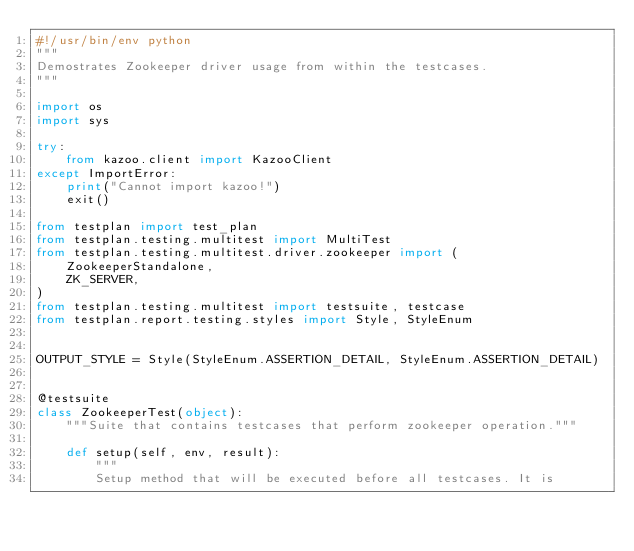<code> <loc_0><loc_0><loc_500><loc_500><_Python_>#!/usr/bin/env python
"""
Demostrates Zookeeper driver usage from within the testcases.
"""

import os
import sys

try:
    from kazoo.client import KazooClient
except ImportError:
    print("Cannot import kazoo!")
    exit()

from testplan import test_plan
from testplan.testing.multitest import MultiTest
from testplan.testing.multitest.driver.zookeeper import (
    ZookeeperStandalone,
    ZK_SERVER,
)
from testplan.testing.multitest import testsuite, testcase
from testplan.report.testing.styles import Style, StyleEnum


OUTPUT_STYLE = Style(StyleEnum.ASSERTION_DETAIL, StyleEnum.ASSERTION_DETAIL)


@testsuite
class ZookeeperTest(object):
    """Suite that contains testcases that perform zookeeper operation."""

    def setup(self, env, result):
        """
        Setup method that will be executed before all testcases. It is</code> 